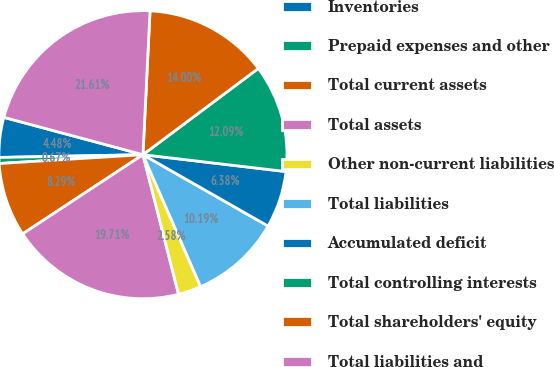Convert chart to OTSL. <chart><loc_0><loc_0><loc_500><loc_500><pie_chart><fcel>Inventories<fcel>Prepaid expenses and other<fcel>Total current assets<fcel>Total assets<fcel>Other non-current liabilities<fcel>Total liabilities<fcel>Accumulated deficit<fcel>Total controlling interests<fcel>Total shareholders' equity<fcel>Total liabilities and<nl><fcel>4.48%<fcel>0.67%<fcel>8.29%<fcel>19.71%<fcel>2.58%<fcel>10.19%<fcel>6.38%<fcel>12.09%<fcel>14.0%<fcel>21.61%<nl></chart> 